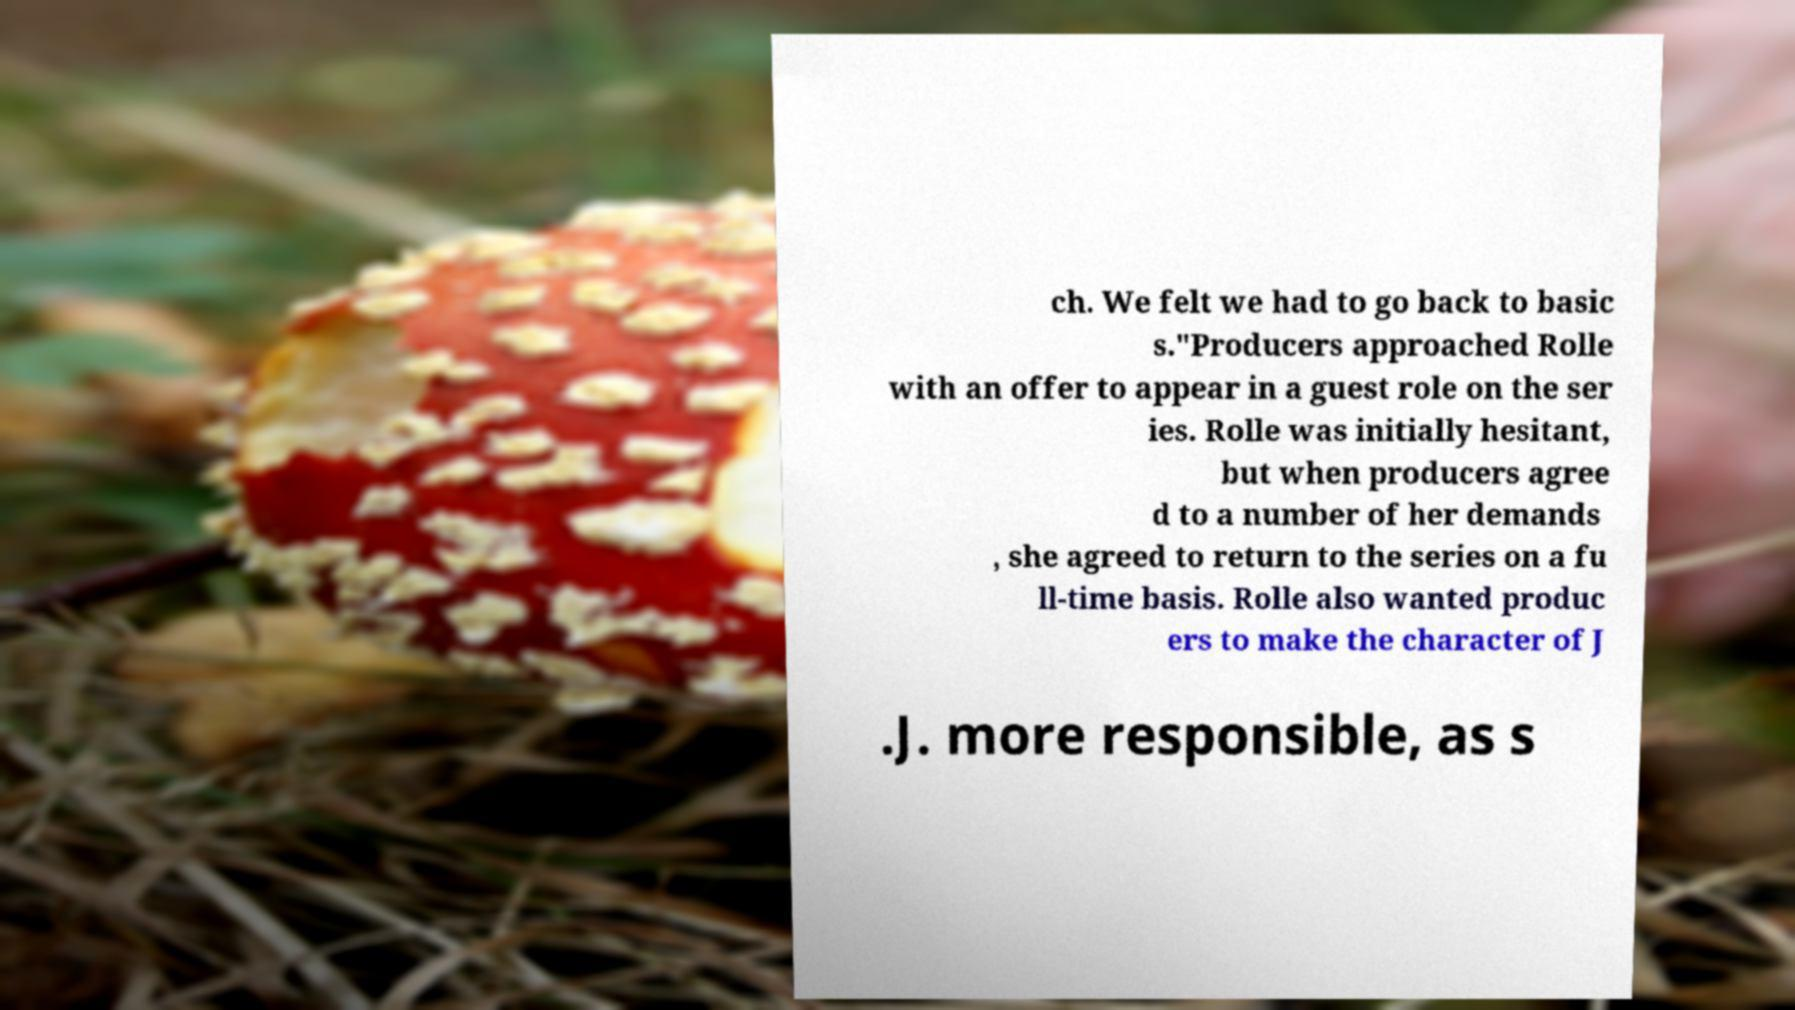What messages or text are displayed in this image? I need them in a readable, typed format. ch. We felt we had to go back to basic s."Producers approached Rolle with an offer to appear in a guest role on the ser ies. Rolle was initially hesitant, but when producers agree d to a number of her demands , she agreed to return to the series on a fu ll-time basis. Rolle also wanted produc ers to make the character of J .J. more responsible, as s 